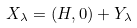Convert formula to latex. <formula><loc_0><loc_0><loc_500><loc_500>X _ { \lambda } = ( H , 0 ) + Y _ { \lambda }</formula> 